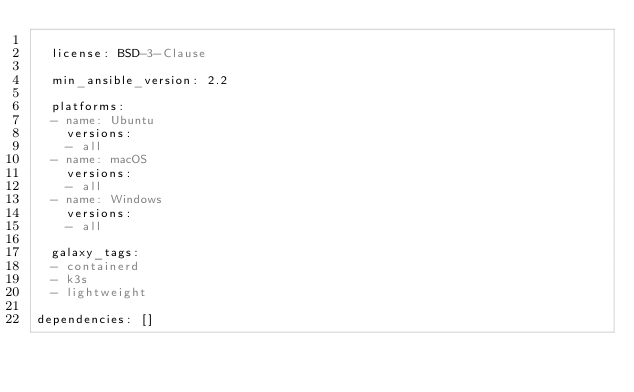<code> <loc_0><loc_0><loc_500><loc_500><_YAML_>
  license: BSD-3-Clause 

  min_ansible_version: 2.2

  platforms:
  - name: Ubuntu 
    versions:
    - all
  - name: macOS 
    versions:
    - all
  - name: Windows 
    versions:
    - all

  galaxy_tags:
  - containerd
  - k3s
  - lightweight

dependencies: []
</code> 